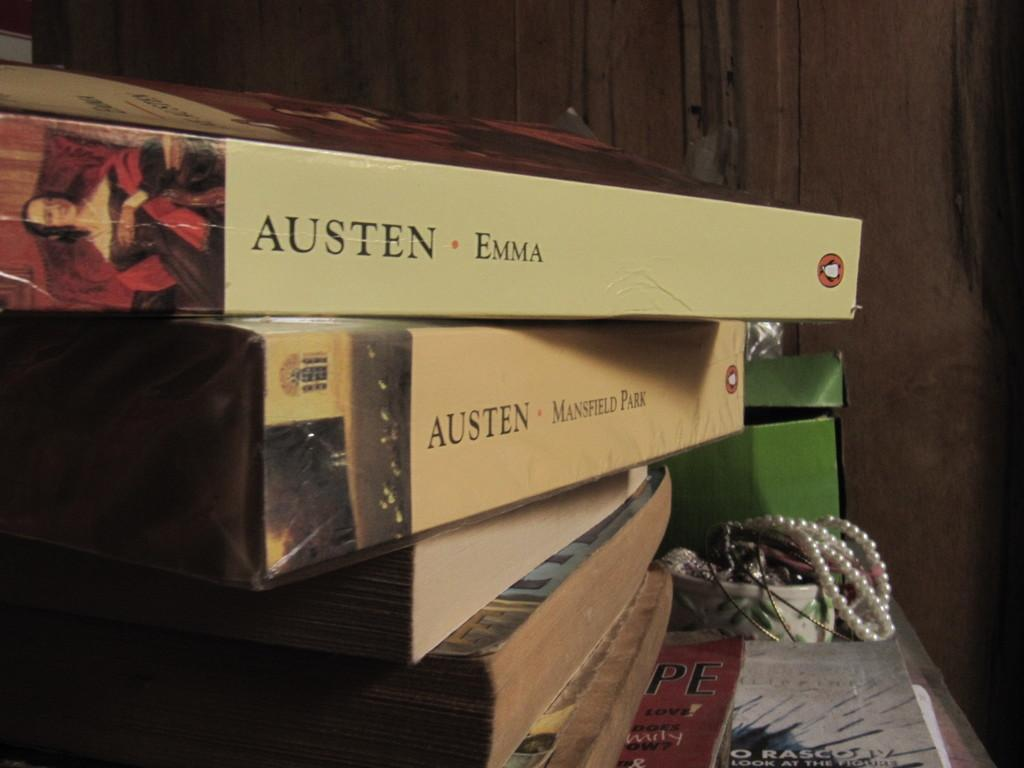<image>
Write a terse but informative summary of the picture. jane austen books stacked one is called emma 